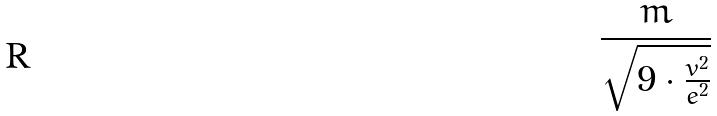<formula> <loc_0><loc_0><loc_500><loc_500>\frac { m } { \sqrt { 9 \cdot \frac { v ^ { 2 } } { e ^ { 2 } } } }</formula> 